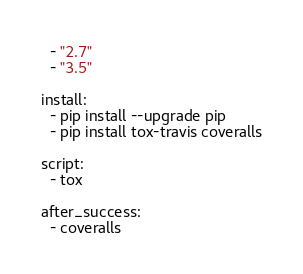<code> <loc_0><loc_0><loc_500><loc_500><_YAML_>  - "2.7"
  - "3.5"

install:
  - pip install --upgrade pip
  - pip install tox-travis coveralls

script:
  - tox

after_success:
  - coveralls
</code> 